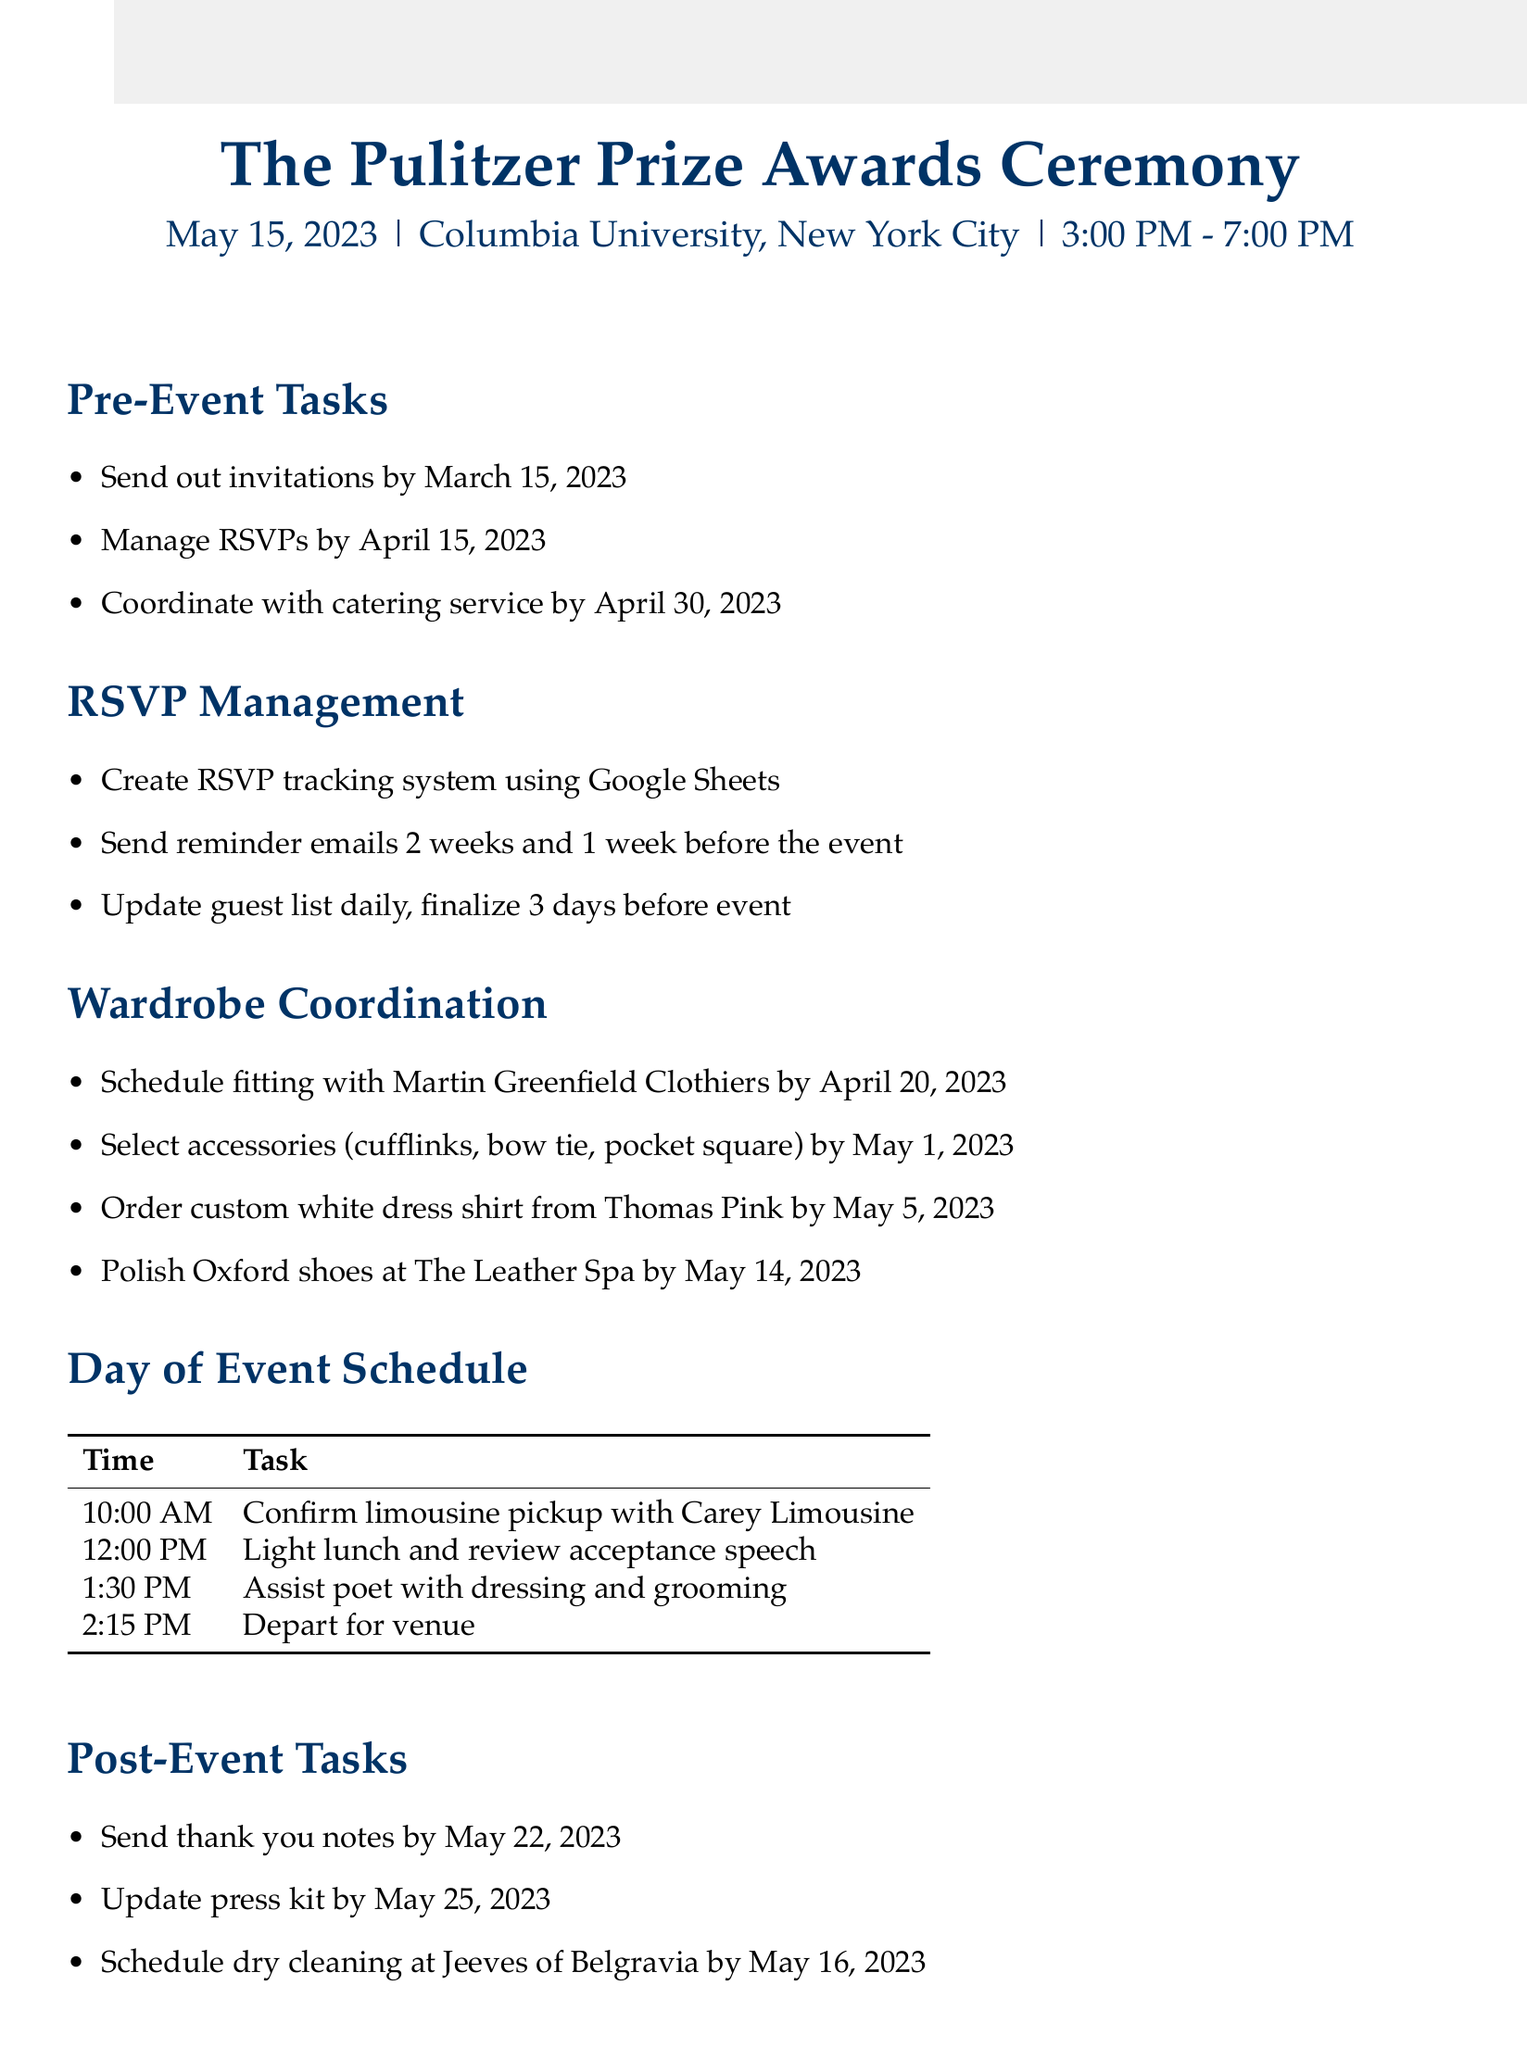what is the name of the event? The document specifies the name of the event as "The Pulitzer Prize Awards Ceremony."
Answer: The Pulitzer Prize Awards Ceremony what is the date of the ceremony? The date mentioned for the ceremony in the document is May 15, 2023.
Answer: May 15, 2023 who is responsible for tailoring the poet's tuxedo? The document notes that "Martin Greenfield Clothiers" is the tailor for the tuxedo fitting.
Answer: Martin Greenfield Clothiers when is the deadline to send out invitations? The deadline for sending out invitations is stated as March 15, 2023.
Answer: March 15, 2023 how many tasks are listed under post-event tasks? The document lists three tasks under post-event tasks.
Answer: 3 what tool is used for RSVP tracking? The RSVP management section specifies that Google Sheets will be used for tracking.
Answer: Google Sheets when should the guest list be updated? The document indicates that the guest list should be updated daily.
Answer: Daily what is the time for the first task on the day of the event? The schedule shows that the first task is set for 10:00 AM.
Answer: 10:00 AM when should thank you notes be sent? The document states that thank you notes should be sent by May 22, 2023.
Answer: May 22, 2023 